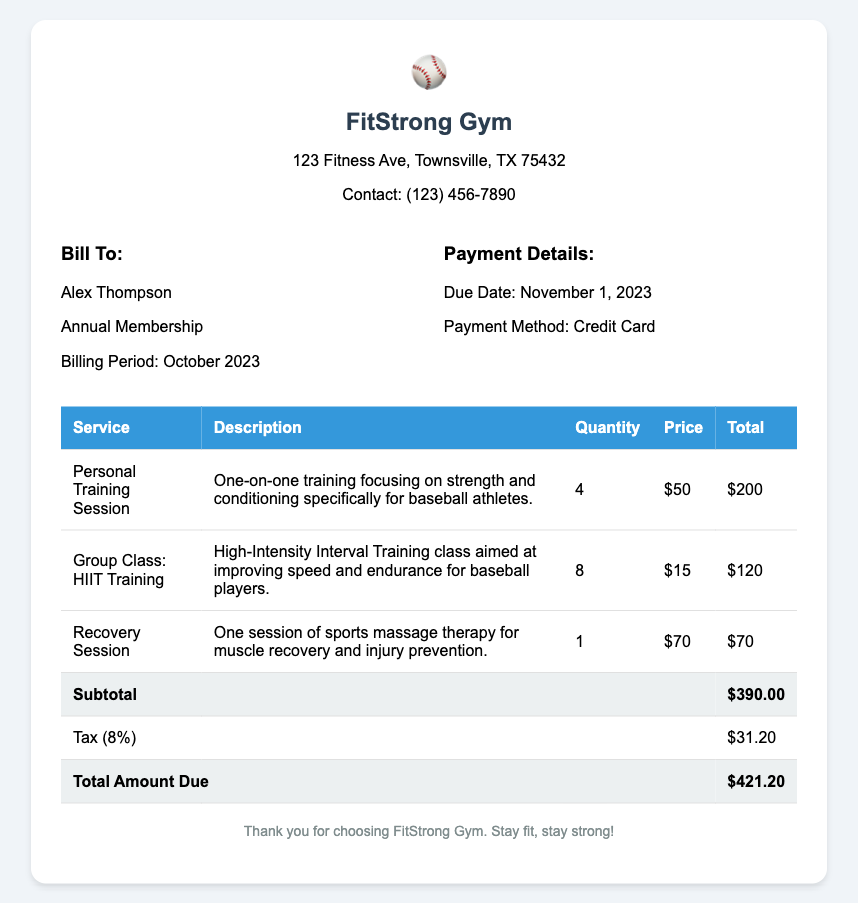What is the total amount due? The total amount due is clearly listed in the document under "Total Amount Due."
Answer: $421.20 How many personal training sessions were included? The document specifies the quantity of personal training sessions provided.
Answer: 4 What is the description of the group class? The document contains a description for the group class listed in the services table.
Answer: High-Intensity Interval Training class aimed at improving speed and endurance for baseball players What is the tax rate applied to the subtotal? The tax amount is calculated based on the subtotal, which is 8% in this case.
Answer: 8% What is the due date for the payment? The due date for the payment is mentioned in the payment details section of the document.
Answer: November 1, 2023 What type of recovery session is included? The document describes the type of recovery session listed in the services table.
Answer: Sports massage therapy for muscle recovery and injury prevention What is the price per group class? The price for each group class is specified in the services breakdown.
Answer: $15 How many group classes were attended? The quantity of group classes attended is listed in the services section of the document.
Answer: 8 What is the subtotal before tax? The subtotal is listed before the tax amount and is shown in the total breakdown.
Answer: $390.00 